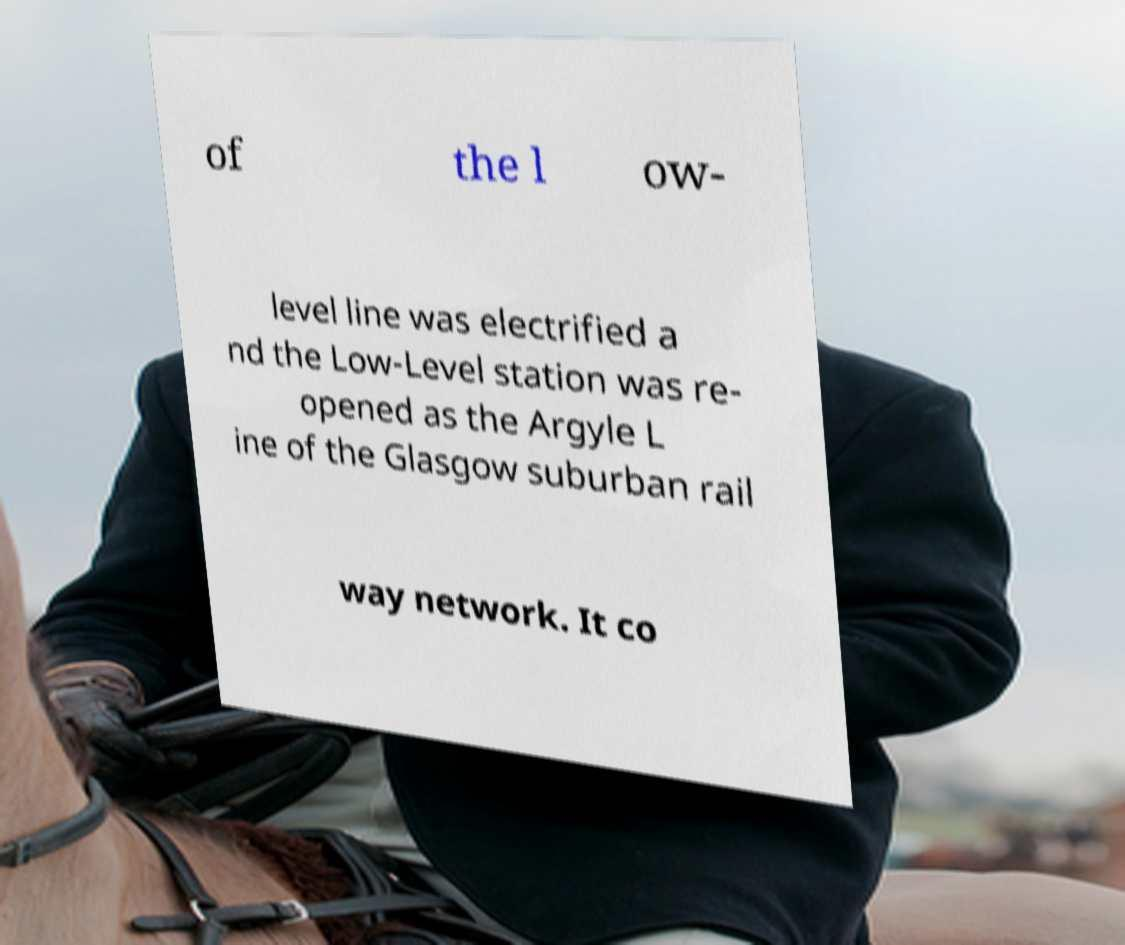Please identify and transcribe the text found in this image. of the l ow- level line was electrified a nd the Low-Level station was re- opened as the Argyle L ine of the Glasgow suburban rail way network. It co 